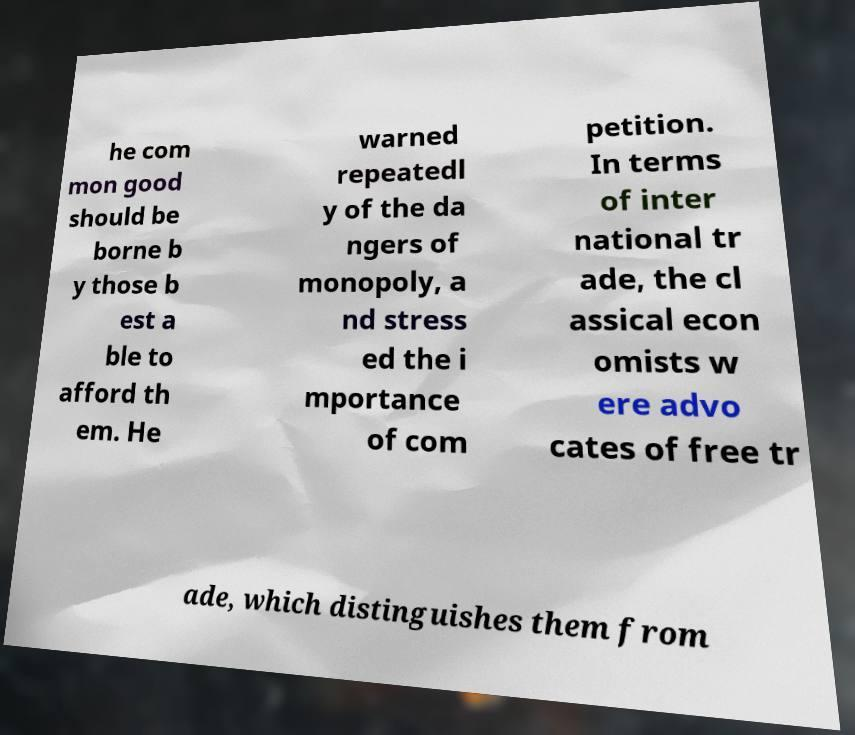There's text embedded in this image that I need extracted. Can you transcribe it verbatim? he com mon good should be borne b y those b est a ble to afford th em. He warned repeatedl y of the da ngers of monopoly, a nd stress ed the i mportance of com petition. In terms of inter national tr ade, the cl assical econ omists w ere advo cates of free tr ade, which distinguishes them from 